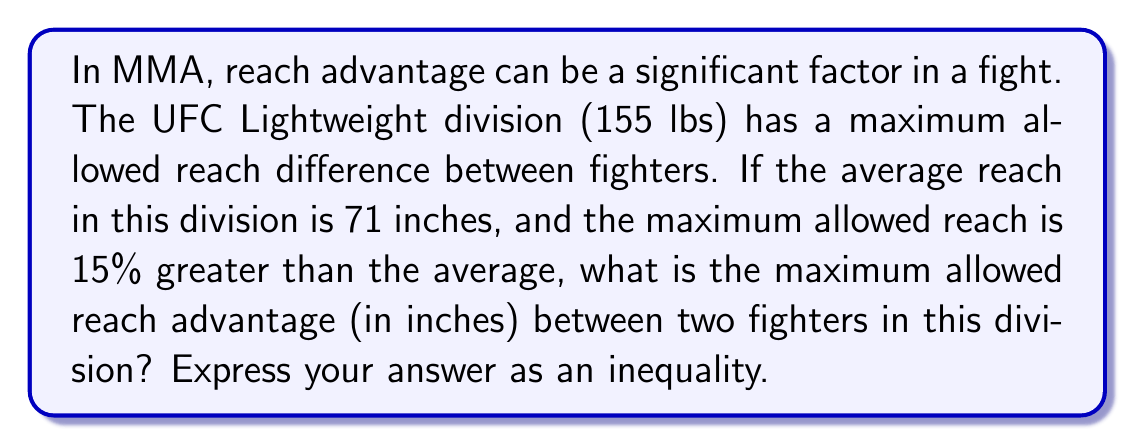Teach me how to tackle this problem. Let's approach this step-by-step:

1) First, we need to calculate the maximum allowed reach:
   Average reach = 71 inches
   Maximum reach = Average reach + 15% of average reach
   $$ \text{Maximum reach} = 71 + 0.15 \times 71 = 71 + 10.65 = 81.65 \text{ inches} $$

2) The reach advantage is the difference between the reaches of two fighters. The maximum reach advantage would occur when one fighter has the maximum allowed reach (81.65 inches) and the other has the minimum reach in the division.

3) While we don't know the exact minimum reach, we know it can't be less than the average reach minus the maximum advantage. Let's call the minimum reach $x$.

4) We can set up an inequality:
   $$ 81.65 - x \leq \text{Maximum allowed reach advantage} $$

5) Since $x$ represents the minimum reach, which we don't know exactly, this inequality gives us the upper bound for the maximum allowed reach advantage.
Answer: $$ \text{Maximum allowed reach advantage} \leq 81.65 - x \text{ inches} $$
where $x$ is the minimum reach in the division (in inches). 